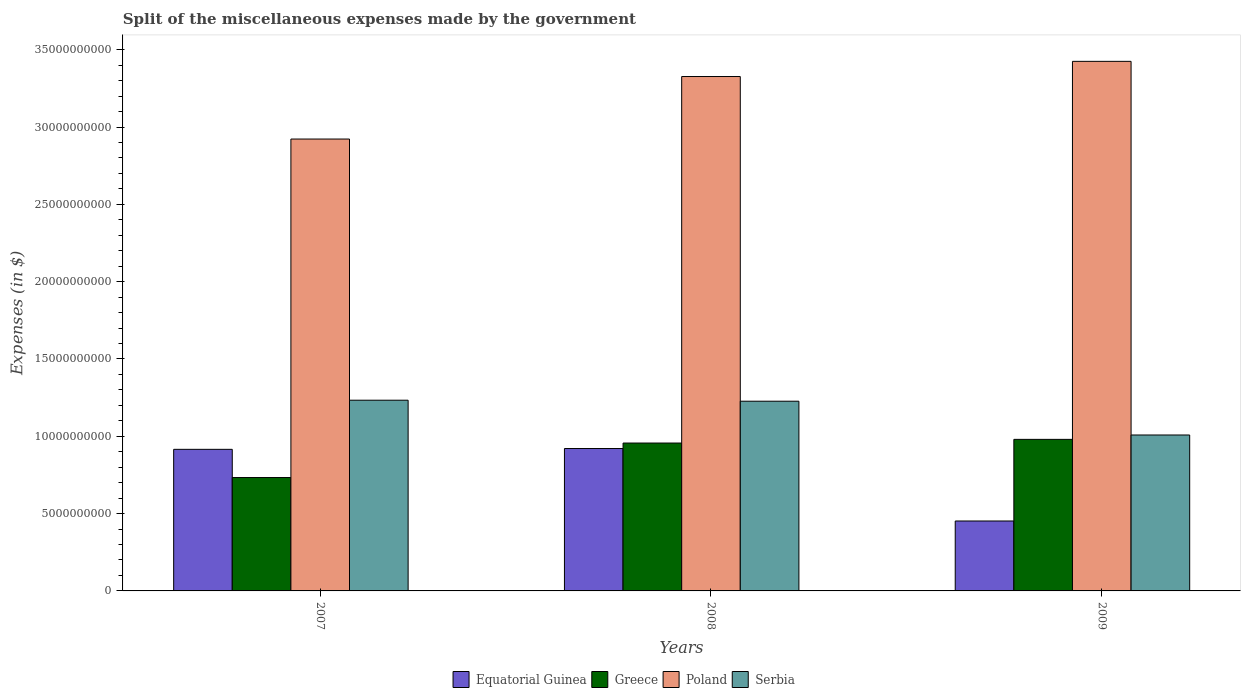How many different coloured bars are there?
Offer a terse response. 4. How many groups of bars are there?
Provide a short and direct response. 3. Are the number of bars on each tick of the X-axis equal?
Provide a succinct answer. Yes. What is the label of the 1st group of bars from the left?
Make the answer very short. 2007. In how many cases, is the number of bars for a given year not equal to the number of legend labels?
Keep it short and to the point. 0. What is the miscellaneous expenses made by the government in Equatorial Guinea in 2009?
Offer a terse response. 4.52e+09. Across all years, what is the maximum miscellaneous expenses made by the government in Poland?
Keep it short and to the point. 3.42e+1. Across all years, what is the minimum miscellaneous expenses made by the government in Greece?
Provide a succinct answer. 7.33e+09. What is the total miscellaneous expenses made by the government in Serbia in the graph?
Offer a terse response. 3.47e+1. What is the difference between the miscellaneous expenses made by the government in Serbia in 2007 and that in 2009?
Offer a very short reply. 2.25e+09. What is the difference between the miscellaneous expenses made by the government in Equatorial Guinea in 2007 and the miscellaneous expenses made by the government in Greece in 2009?
Provide a short and direct response. -6.45e+08. What is the average miscellaneous expenses made by the government in Poland per year?
Keep it short and to the point. 3.22e+1. In the year 2009, what is the difference between the miscellaneous expenses made by the government in Equatorial Guinea and miscellaneous expenses made by the government in Serbia?
Provide a succinct answer. -5.56e+09. In how many years, is the miscellaneous expenses made by the government in Equatorial Guinea greater than 25000000000 $?
Provide a short and direct response. 0. What is the ratio of the miscellaneous expenses made by the government in Greece in 2007 to that in 2009?
Keep it short and to the point. 0.75. Is the miscellaneous expenses made by the government in Serbia in 2007 less than that in 2008?
Give a very brief answer. No. Is the difference between the miscellaneous expenses made by the government in Equatorial Guinea in 2007 and 2009 greater than the difference between the miscellaneous expenses made by the government in Serbia in 2007 and 2009?
Offer a terse response. Yes. What is the difference between the highest and the second highest miscellaneous expenses made by the government in Greece?
Your answer should be compact. 2.38e+08. What is the difference between the highest and the lowest miscellaneous expenses made by the government in Poland?
Your response must be concise. 5.02e+09. In how many years, is the miscellaneous expenses made by the government in Equatorial Guinea greater than the average miscellaneous expenses made by the government in Equatorial Guinea taken over all years?
Provide a short and direct response. 2. What does the 4th bar from the left in 2008 represents?
Keep it short and to the point. Serbia. What does the 4th bar from the right in 2009 represents?
Keep it short and to the point. Equatorial Guinea. Is it the case that in every year, the sum of the miscellaneous expenses made by the government in Greece and miscellaneous expenses made by the government in Poland is greater than the miscellaneous expenses made by the government in Equatorial Guinea?
Your response must be concise. Yes. Are all the bars in the graph horizontal?
Keep it short and to the point. No. How many years are there in the graph?
Provide a succinct answer. 3. What is the difference between two consecutive major ticks on the Y-axis?
Ensure brevity in your answer.  5.00e+09. Are the values on the major ticks of Y-axis written in scientific E-notation?
Your answer should be compact. No. Does the graph contain any zero values?
Your response must be concise. No. Does the graph contain grids?
Your answer should be very brief. No. Where does the legend appear in the graph?
Offer a very short reply. Bottom center. What is the title of the graph?
Offer a terse response. Split of the miscellaneous expenses made by the government. Does "Tanzania" appear as one of the legend labels in the graph?
Provide a succinct answer. No. What is the label or title of the Y-axis?
Give a very brief answer. Expenses (in $). What is the Expenses (in $) of Equatorial Guinea in 2007?
Give a very brief answer. 9.16e+09. What is the Expenses (in $) of Greece in 2007?
Provide a short and direct response. 7.33e+09. What is the Expenses (in $) of Poland in 2007?
Provide a short and direct response. 2.92e+1. What is the Expenses (in $) in Serbia in 2007?
Your response must be concise. 1.23e+1. What is the Expenses (in $) in Equatorial Guinea in 2008?
Offer a terse response. 9.21e+09. What is the Expenses (in $) of Greece in 2008?
Your answer should be compact. 9.56e+09. What is the Expenses (in $) of Poland in 2008?
Provide a succinct answer. 3.33e+1. What is the Expenses (in $) of Serbia in 2008?
Offer a terse response. 1.23e+1. What is the Expenses (in $) of Equatorial Guinea in 2009?
Your answer should be very brief. 4.52e+09. What is the Expenses (in $) of Greece in 2009?
Offer a very short reply. 9.80e+09. What is the Expenses (in $) in Poland in 2009?
Your answer should be very brief. 3.42e+1. What is the Expenses (in $) of Serbia in 2009?
Make the answer very short. 1.01e+1. Across all years, what is the maximum Expenses (in $) of Equatorial Guinea?
Make the answer very short. 9.21e+09. Across all years, what is the maximum Expenses (in $) in Greece?
Your answer should be very brief. 9.80e+09. Across all years, what is the maximum Expenses (in $) of Poland?
Your response must be concise. 3.42e+1. Across all years, what is the maximum Expenses (in $) in Serbia?
Make the answer very short. 1.23e+1. Across all years, what is the minimum Expenses (in $) of Equatorial Guinea?
Provide a succinct answer. 4.52e+09. Across all years, what is the minimum Expenses (in $) of Greece?
Provide a short and direct response. 7.33e+09. Across all years, what is the minimum Expenses (in $) in Poland?
Give a very brief answer. 2.92e+1. Across all years, what is the minimum Expenses (in $) in Serbia?
Offer a terse response. 1.01e+1. What is the total Expenses (in $) in Equatorial Guinea in the graph?
Provide a short and direct response. 2.29e+1. What is the total Expenses (in $) in Greece in the graph?
Ensure brevity in your answer.  2.67e+1. What is the total Expenses (in $) of Poland in the graph?
Offer a very short reply. 9.67e+1. What is the total Expenses (in $) in Serbia in the graph?
Provide a succinct answer. 3.47e+1. What is the difference between the Expenses (in $) of Equatorial Guinea in 2007 and that in 2008?
Your answer should be very brief. -5.30e+07. What is the difference between the Expenses (in $) in Greece in 2007 and that in 2008?
Offer a terse response. -2.23e+09. What is the difference between the Expenses (in $) of Poland in 2007 and that in 2008?
Provide a short and direct response. -4.04e+09. What is the difference between the Expenses (in $) in Serbia in 2007 and that in 2008?
Keep it short and to the point. 6.43e+07. What is the difference between the Expenses (in $) of Equatorial Guinea in 2007 and that in 2009?
Provide a short and direct response. 4.63e+09. What is the difference between the Expenses (in $) of Greece in 2007 and that in 2009?
Provide a succinct answer. -2.47e+09. What is the difference between the Expenses (in $) in Poland in 2007 and that in 2009?
Give a very brief answer. -5.02e+09. What is the difference between the Expenses (in $) in Serbia in 2007 and that in 2009?
Your answer should be very brief. 2.25e+09. What is the difference between the Expenses (in $) of Equatorial Guinea in 2008 and that in 2009?
Ensure brevity in your answer.  4.69e+09. What is the difference between the Expenses (in $) of Greece in 2008 and that in 2009?
Make the answer very short. -2.38e+08. What is the difference between the Expenses (in $) of Poland in 2008 and that in 2009?
Offer a very short reply. -9.81e+08. What is the difference between the Expenses (in $) in Serbia in 2008 and that in 2009?
Provide a succinct answer. 2.19e+09. What is the difference between the Expenses (in $) of Equatorial Guinea in 2007 and the Expenses (in $) of Greece in 2008?
Your answer should be very brief. -4.07e+08. What is the difference between the Expenses (in $) of Equatorial Guinea in 2007 and the Expenses (in $) of Poland in 2008?
Your answer should be compact. -2.41e+1. What is the difference between the Expenses (in $) in Equatorial Guinea in 2007 and the Expenses (in $) in Serbia in 2008?
Ensure brevity in your answer.  -3.11e+09. What is the difference between the Expenses (in $) in Greece in 2007 and the Expenses (in $) in Poland in 2008?
Offer a very short reply. -2.59e+1. What is the difference between the Expenses (in $) in Greece in 2007 and the Expenses (in $) in Serbia in 2008?
Give a very brief answer. -4.94e+09. What is the difference between the Expenses (in $) of Poland in 2007 and the Expenses (in $) of Serbia in 2008?
Ensure brevity in your answer.  1.70e+1. What is the difference between the Expenses (in $) of Equatorial Guinea in 2007 and the Expenses (in $) of Greece in 2009?
Offer a terse response. -6.45e+08. What is the difference between the Expenses (in $) in Equatorial Guinea in 2007 and the Expenses (in $) in Poland in 2009?
Keep it short and to the point. -2.51e+1. What is the difference between the Expenses (in $) of Equatorial Guinea in 2007 and the Expenses (in $) of Serbia in 2009?
Give a very brief answer. -9.27e+08. What is the difference between the Expenses (in $) of Greece in 2007 and the Expenses (in $) of Poland in 2009?
Your answer should be very brief. -2.69e+1. What is the difference between the Expenses (in $) of Greece in 2007 and the Expenses (in $) of Serbia in 2009?
Your answer should be very brief. -2.75e+09. What is the difference between the Expenses (in $) of Poland in 2007 and the Expenses (in $) of Serbia in 2009?
Keep it short and to the point. 1.91e+1. What is the difference between the Expenses (in $) in Equatorial Guinea in 2008 and the Expenses (in $) in Greece in 2009?
Offer a very short reply. -5.92e+08. What is the difference between the Expenses (in $) of Equatorial Guinea in 2008 and the Expenses (in $) of Poland in 2009?
Offer a terse response. -2.50e+1. What is the difference between the Expenses (in $) in Equatorial Guinea in 2008 and the Expenses (in $) in Serbia in 2009?
Your answer should be very brief. -8.74e+08. What is the difference between the Expenses (in $) in Greece in 2008 and the Expenses (in $) in Poland in 2009?
Provide a short and direct response. -2.47e+1. What is the difference between the Expenses (in $) of Greece in 2008 and the Expenses (in $) of Serbia in 2009?
Keep it short and to the point. -5.20e+08. What is the difference between the Expenses (in $) in Poland in 2008 and the Expenses (in $) in Serbia in 2009?
Offer a very short reply. 2.32e+1. What is the average Expenses (in $) of Equatorial Guinea per year?
Ensure brevity in your answer.  7.63e+09. What is the average Expenses (in $) of Greece per year?
Give a very brief answer. 8.90e+09. What is the average Expenses (in $) of Poland per year?
Your answer should be very brief. 3.22e+1. What is the average Expenses (in $) in Serbia per year?
Your response must be concise. 1.16e+1. In the year 2007, what is the difference between the Expenses (in $) of Equatorial Guinea and Expenses (in $) of Greece?
Make the answer very short. 1.82e+09. In the year 2007, what is the difference between the Expenses (in $) in Equatorial Guinea and Expenses (in $) in Poland?
Your answer should be compact. -2.01e+1. In the year 2007, what is the difference between the Expenses (in $) in Equatorial Guinea and Expenses (in $) in Serbia?
Keep it short and to the point. -3.18e+09. In the year 2007, what is the difference between the Expenses (in $) in Greece and Expenses (in $) in Poland?
Offer a very short reply. -2.19e+1. In the year 2007, what is the difference between the Expenses (in $) in Greece and Expenses (in $) in Serbia?
Your response must be concise. -5.00e+09. In the year 2007, what is the difference between the Expenses (in $) of Poland and Expenses (in $) of Serbia?
Offer a very short reply. 1.69e+1. In the year 2008, what is the difference between the Expenses (in $) in Equatorial Guinea and Expenses (in $) in Greece?
Give a very brief answer. -3.54e+08. In the year 2008, what is the difference between the Expenses (in $) of Equatorial Guinea and Expenses (in $) of Poland?
Your answer should be very brief. -2.41e+1. In the year 2008, what is the difference between the Expenses (in $) of Equatorial Guinea and Expenses (in $) of Serbia?
Your answer should be very brief. -3.06e+09. In the year 2008, what is the difference between the Expenses (in $) in Greece and Expenses (in $) in Poland?
Ensure brevity in your answer.  -2.37e+1. In the year 2008, what is the difference between the Expenses (in $) of Greece and Expenses (in $) of Serbia?
Ensure brevity in your answer.  -2.71e+09. In the year 2008, what is the difference between the Expenses (in $) in Poland and Expenses (in $) in Serbia?
Your answer should be compact. 2.10e+1. In the year 2009, what is the difference between the Expenses (in $) of Equatorial Guinea and Expenses (in $) of Greece?
Provide a succinct answer. -5.28e+09. In the year 2009, what is the difference between the Expenses (in $) of Equatorial Guinea and Expenses (in $) of Poland?
Provide a short and direct response. -2.97e+1. In the year 2009, what is the difference between the Expenses (in $) in Equatorial Guinea and Expenses (in $) in Serbia?
Provide a short and direct response. -5.56e+09. In the year 2009, what is the difference between the Expenses (in $) in Greece and Expenses (in $) in Poland?
Ensure brevity in your answer.  -2.44e+1. In the year 2009, what is the difference between the Expenses (in $) of Greece and Expenses (in $) of Serbia?
Offer a terse response. -2.82e+08. In the year 2009, what is the difference between the Expenses (in $) in Poland and Expenses (in $) in Serbia?
Offer a very short reply. 2.42e+1. What is the ratio of the Expenses (in $) in Greece in 2007 to that in 2008?
Keep it short and to the point. 0.77. What is the ratio of the Expenses (in $) in Poland in 2007 to that in 2008?
Make the answer very short. 0.88. What is the ratio of the Expenses (in $) in Equatorial Guinea in 2007 to that in 2009?
Your answer should be compact. 2.02. What is the ratio of the Expenses (in $) of Greece in 2007 to that in 2009?
Your answer should be compact. 0.75. What is the ratio of the Expenses (in $) of Poland in 2007 to that in 2009?
Keep it short and to the point. 0.85. What is the ratio of the Expenses (in $) in Serbia in 2007 to that in 2009?
Your response must be concise. 1.22. What is the ratio of the Expenses (in $) in Equatorial Guinea in 2008 to that in 2009?
Provide a short and direct response. 2.04. What is the ratio of the Expenses (in $) of Greece in 2008 to that in 2009?
Provide a short and direct response. 0.98. What is the ratio of the Expenses (in $) of Poland in 2008 to that in 2009?
Give a very brief answer. 0.97. What is the ratio of the Expenses (in $) of Serbia in 2008 to that in 2009?
Keep it short and to the point. 1.22. What is the difference between the highest and the second highest Expenses (in $) in Equatorial Guinea?
Your response must be concise. 5.30e+07. What is the difference between the highest and the second highest Expenses (in $) in Greece?
Give a very brief answer. 2.38e+08. What is the difference between the highest and the second highest Expenses (in $) in Poland?
Your answer should be very brief. 9.81e+08. What is the difference between the highest and the second highest Expenses (in $) of Serbia?
Provide a succinct answer. 6.43e+07. What is the difference between the highest and the lowest Expenses (in $) of Equatorial Guinea?
Ensure brevity in your answer.  4.69e+09. What is the difference between the highest and the lowest Expenses (in $) of Greece?
Offer a terse response. 2.47e+09. What is the difference between the highest and the lowest Expenses (in $) of Poland?
Your response must be concise. 5.02e+09. What is the difference between the highest and the lowest Expenses (in $) of Serbia?
Make the answer very short. 2.25e+09. 